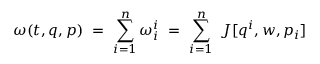<formula> <loc_0><loc_0><loc_500><loc_500>\omega ( t , q , p ) \ = \ \sum _ { i = 1 } ^ { n } \omega _ { i } ^ { i } \ = \ \sum _ { i = 1 } ^ { n } \ J [ q ^ { i } , w , p _ { i } ]</formula> 